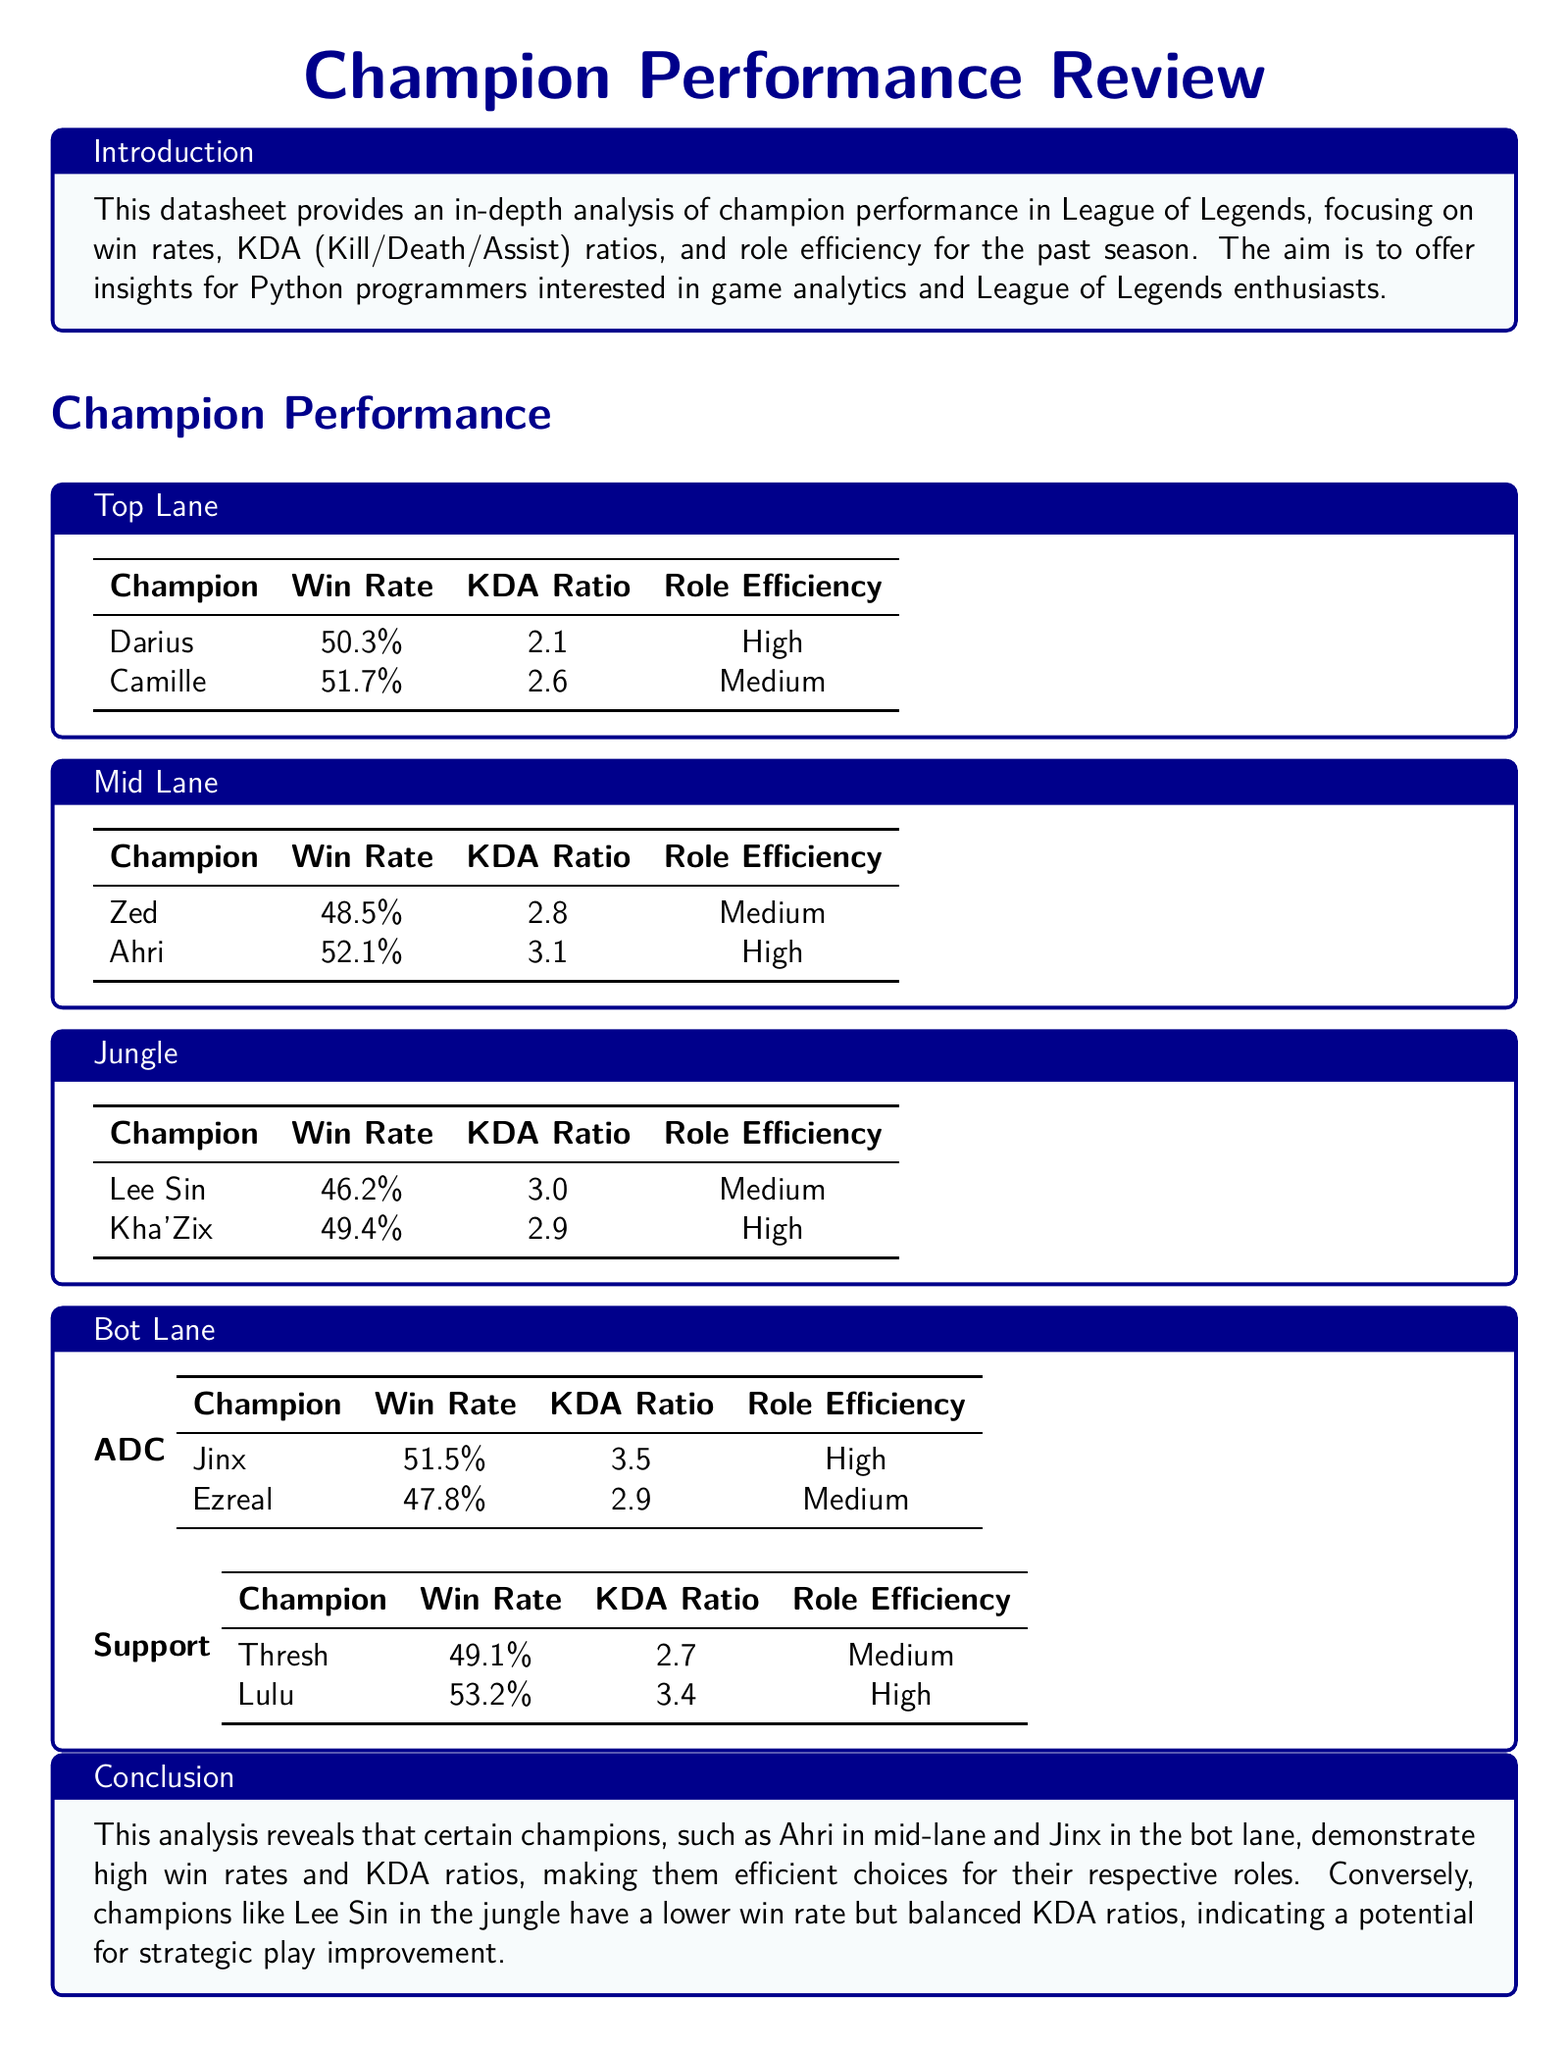What is the win rate of Camille? The win rate of Camille is provided in the Top Lane section of the document.
Answer: 51.7% What is the KDA ratio of Ahri? The KDA ratio of Ahri can be found in the Mid Lane section of the document.
Answer: 3.1 Which champion has the highest win rate in the Bot Lane ADC category? The champion with the highest win rate in the Bot Lane ADC category is listed in the ADC subsection.
Answer: Jinx What role efficiency does Kha'Zix have? The role efficiency of Kha'Zix is mentioned in the Jungle section of the document.
Answer: High Which champion in the Jungle has a higher KDA ratio than Lee Sin? The comparison involves KDA ratios from the Jungle section of the document.
Answer: None Which lane has a champion with a win rate below 50%? The question refers to the win rates listed in the corresponding sections of the document.
Answer: Jungle What is the overall purpose of this datasheet? The introductory section of the document describes its aim.
Answer: To offer insights for Python programmers interested in game analytics and League of Legends enthusiasts Which champion in the Support category has the highest win rate? This information is available in the Bot Lane Support subsection of the document.
Answer: Lulu 